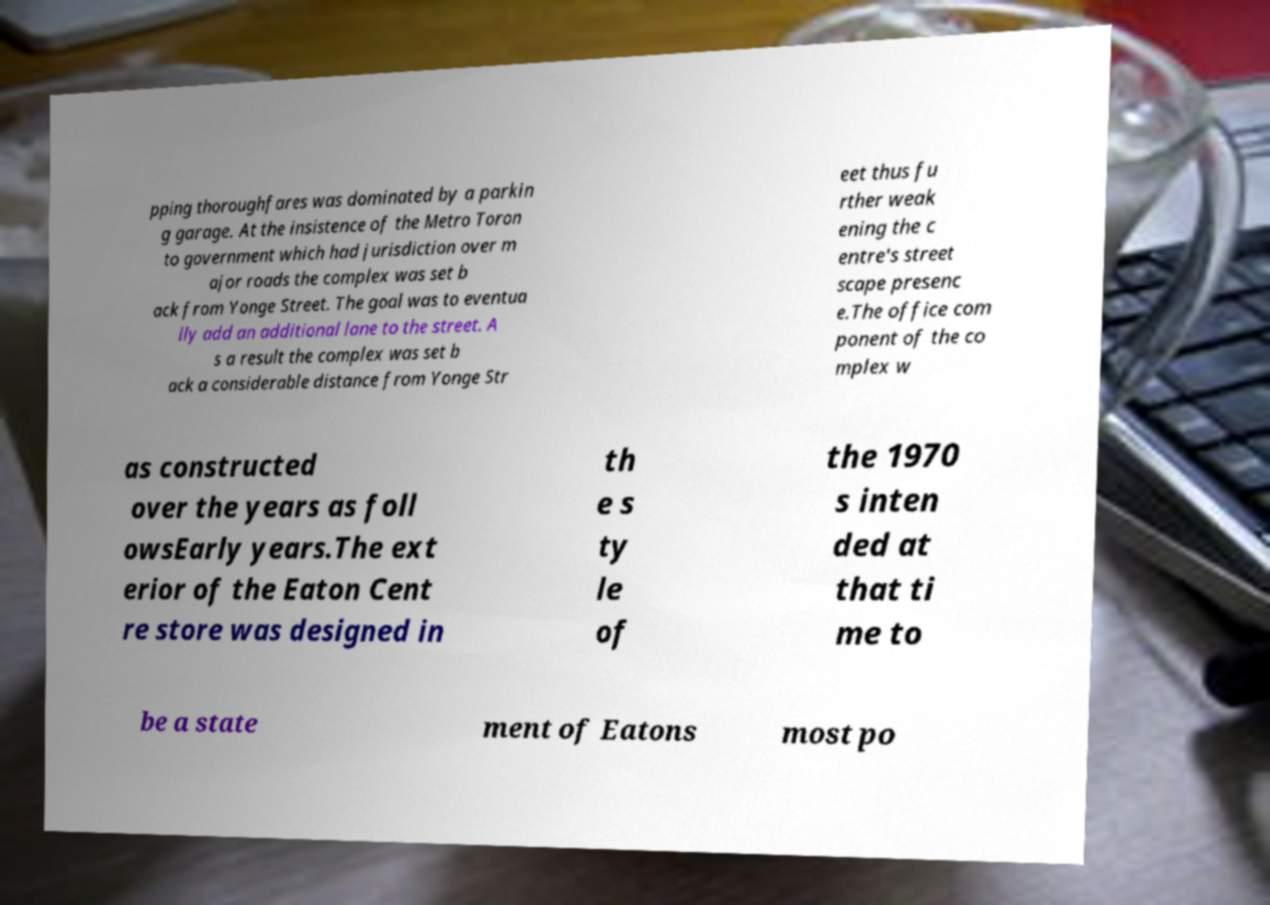Could you assist in decoding the text presented in this image and type it out clearly? pping thoroughfares was dominated by a parkin g garage. At the insistence of the Metro Toron to government which had jurisdiction over m ajor roads the complex was set b ack from Yonge Street. The goal was to eventua lly add an additional lane to the street. A s a result the complex was set b ack a considerable distance from Yonge Str eet thus fu rther weak ening the c entre's street scape presenc e.The office com ponent of the co mplex w as constructed over the years as foll owsEarly years.The ext erior of the Eaton Cent re store was designed in th e s ty le of the 1970 s inten ded at that ti me to be a state ment of Eatons most po 